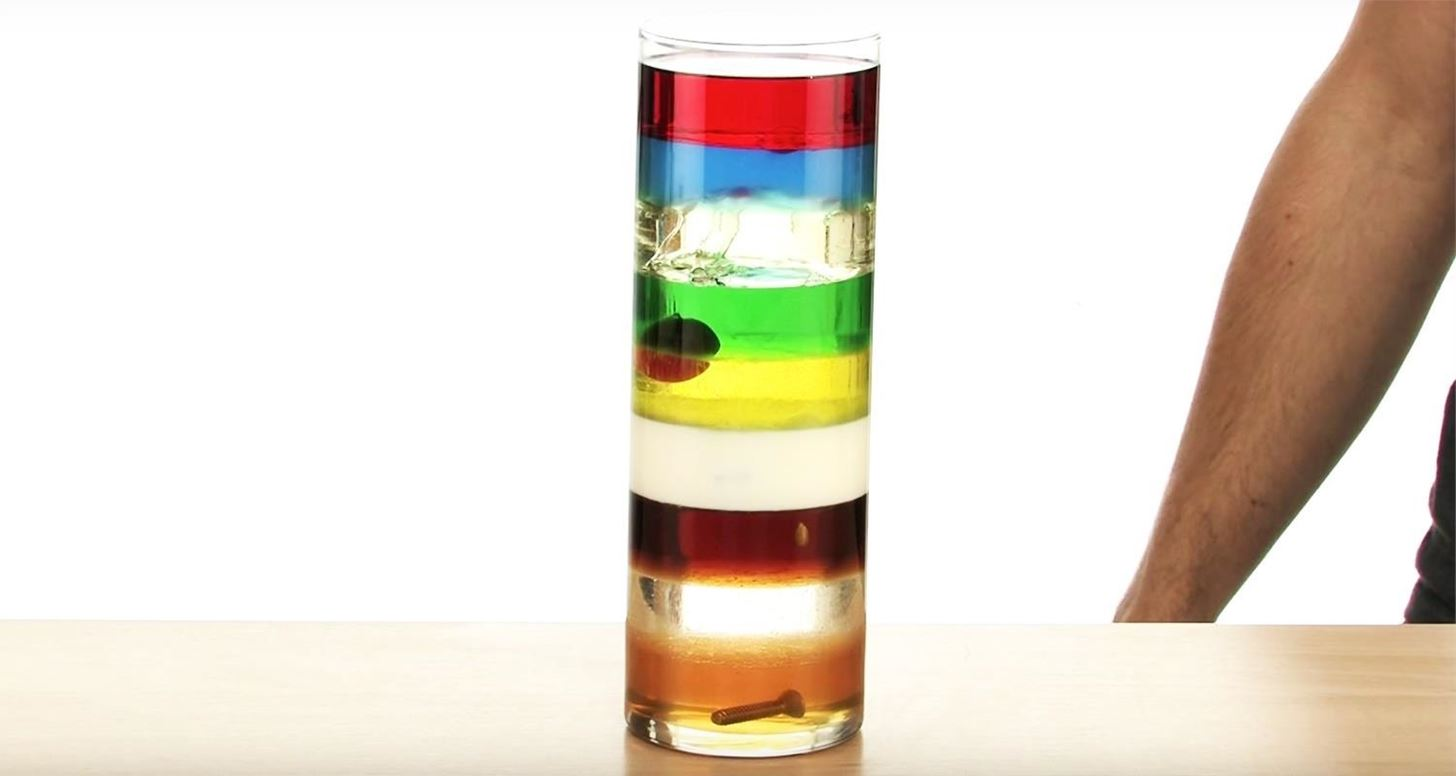Based on the image, estimate the density order of the liquids from top to bottom. Based on the image, here is an estimation of the density order of the liquids from top to bottom:
1. Red liquid (least dense)
2. Blue liquid
3. Green liquid
4. Yellow liquid
5. White liquid
6. Brown liquid
7. Clear liquid (most dense) How could we experimentally determine the exact densities of these liquids? To experimentally determine the exact densities of these liquids, you would follow these steps:
1. **Measure the Volume:** Pour a known volume of each liquid (e.g., 100 milliliters) into a graduated cylinder.
2. **Weigh the Liquid:** Use a balance to measure the mass of the liquid in grams. It's important to use a precise balance for accuracy.
3. **Calculate the Density:** Use the formula density = mass/volume. Divide the mass of the liquid by its volume to find the density, expressed in grams per milliliter (g/mL).
4. **Repeat for Each Liquid:** Perform these steps for each of the liquids to obtain their densities.
5. **Record and Compare:** Make a chart of your findings to compare the densities of the different liquids, which will confirm the order observed in the image. Suppose we replace one of the liquids with honey. Predict where this new layer would settle. Honey has a relatively high density compared to many common liquids. If honey were added to this column of liquids, it is expected to settle near the bottom, possibly just above the clear liquid, if the clear liquid is the densest. The exact position would depend on the exact densities of the current liquids, but honey's higher density should ensure it is closer to the bottom layers. 